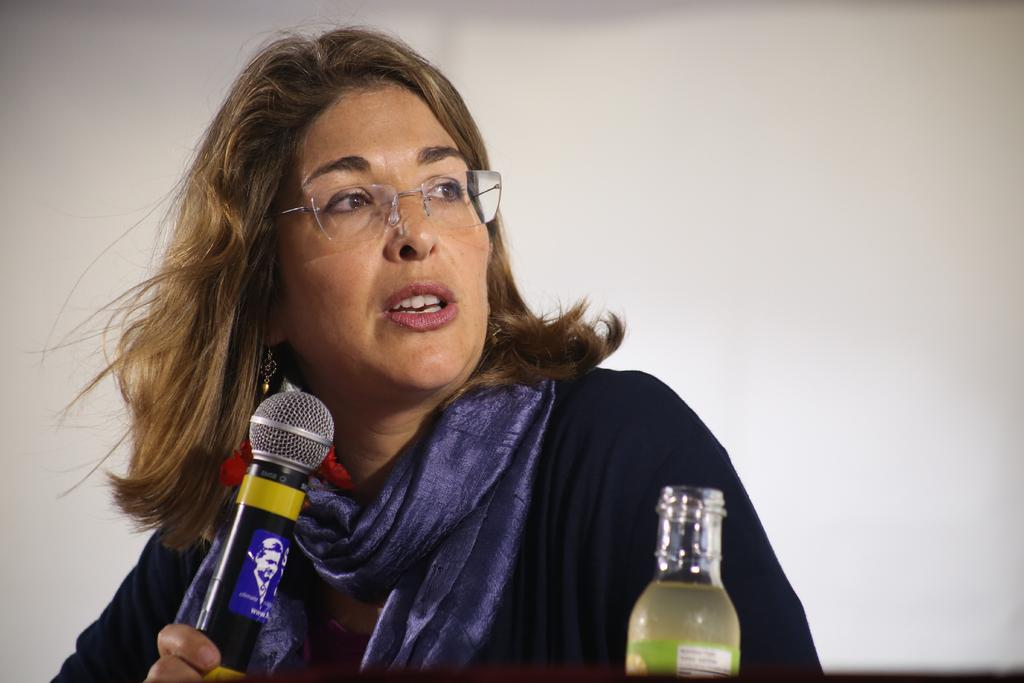Who is the main subject in the image? There is a woman in the image. What is the woman holding in the image? The woman is holding a microphone. Can you identify any other objects in the image? Yes, there is a bottle visible in the image. What type of structure can be seen in the background of the image? There is no structure visible in the background of the image. What kind of stitch is the woman using to hold the microphone? The woman is not using a stitch to hold the microphone; she is simply holding it in her hand. 